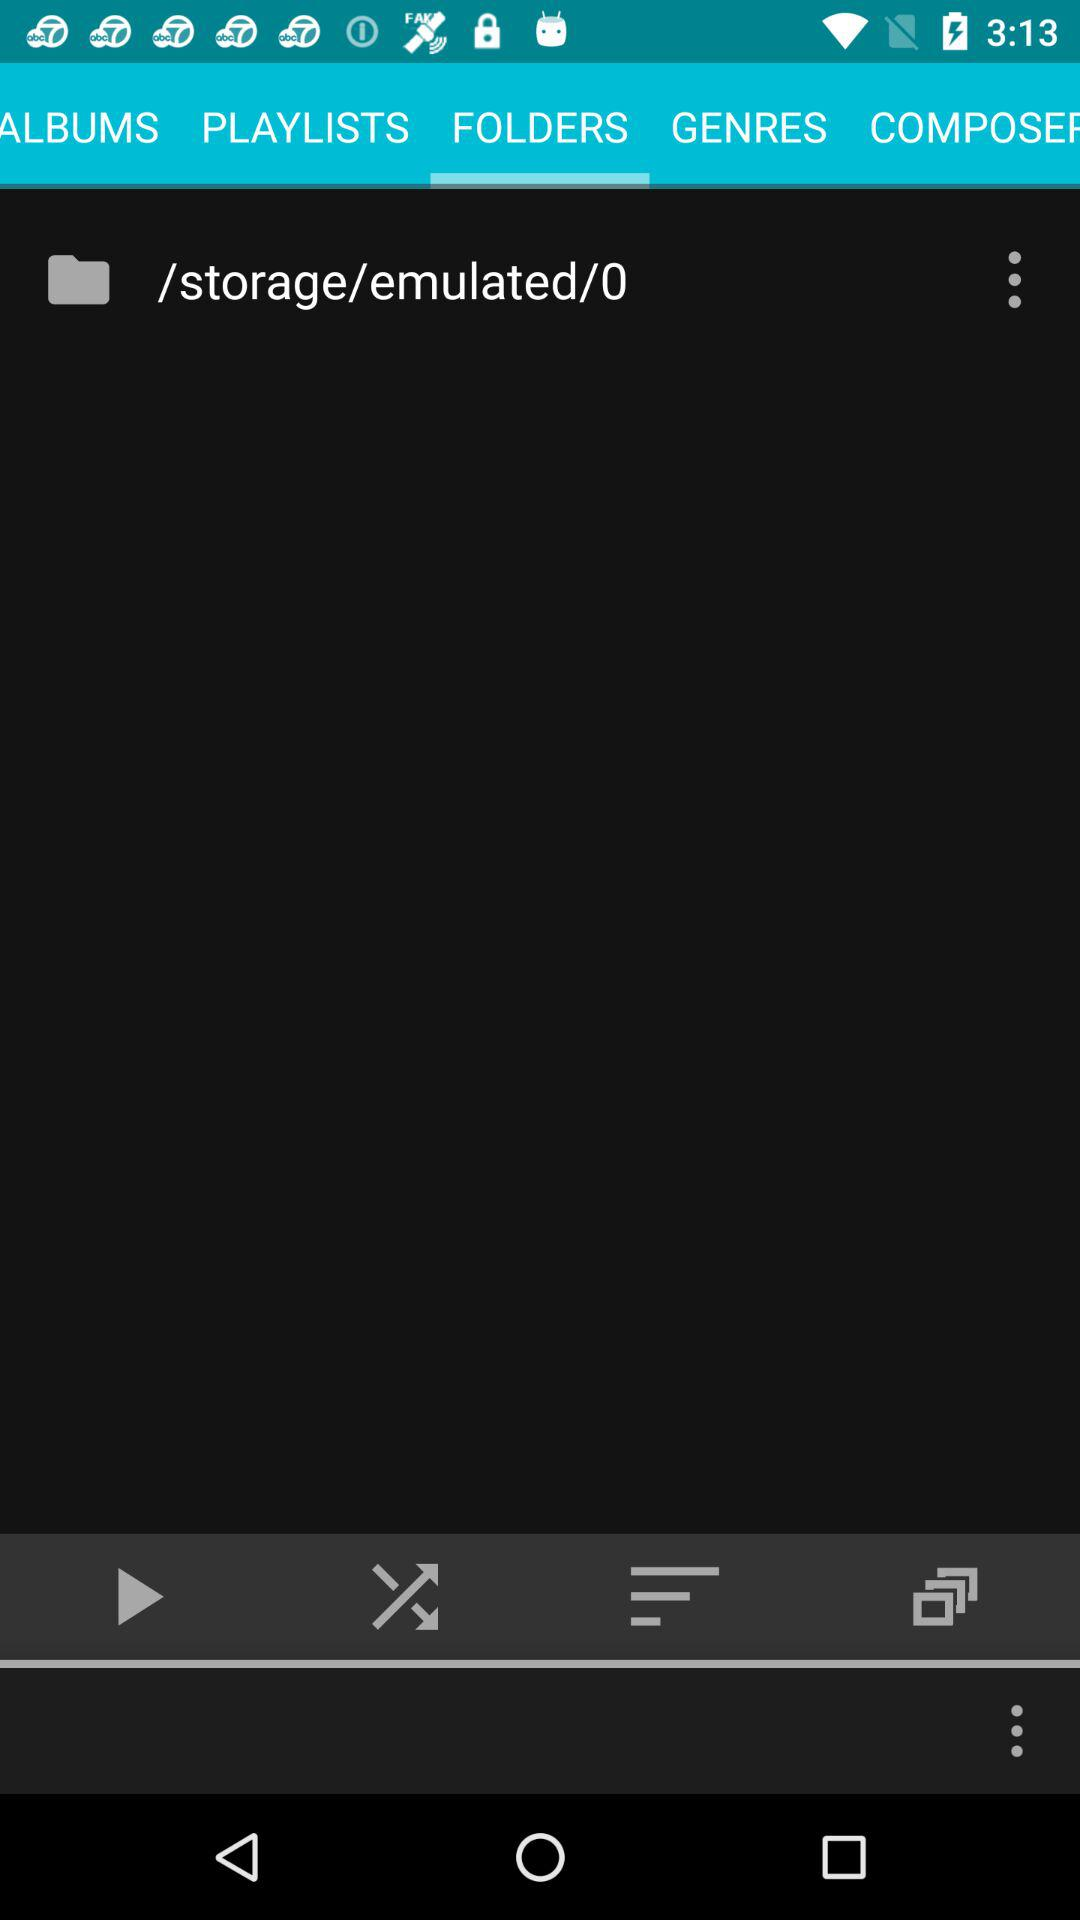Which tab is selected? The selected tab is "FOLDERS". 